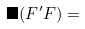<formula> <loc_0><loc_0><loc_500><loc_500>\blacksquare ( F ^ { \prime } F ) =</formula> 